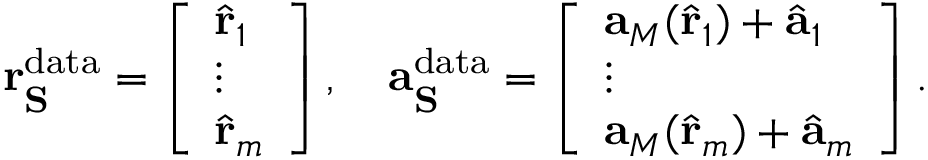Convert formula to latex. <formula><loc_0><loc_0><loc_500><loc_500>r _ { S } ^ { d a t a } = \left [ \begin{array} { l } { \hat { r } _ { 1 } } \\ { \vdots } \\ { \hat { r } _ { m } } \end{array} \right ] , \quad a _ { S } ^ { d a t a } = \left [ \begin{array} { l } { a _ { M } ( \hat { r } _ { 1 } ) + \hat { a } _ { 1 } } \\ { \vdots } \\ { a _ { M } ( \hat { r } _ { m } ) + \hat { a } _ { m } } \end{array} \right ] .</formula> 